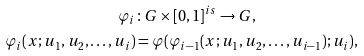<formula> <loc_0><loc_0><loc_500><loc_500>\varphi _ { i } & \colon G \times [ 0 , 1 ] ^ { i s } \to G , \\ \varphi _ { i } ( x ; u _ { 1 } , u _ { 2 } , \dots , u _ { i } ) & = \varphi ( \varphi _ { i - 1 } ( x ; u _ { 1 } , u _ { 2 } , \dots , u _ { i - 1 } ) ; u _ { i } ) ,</formula> 